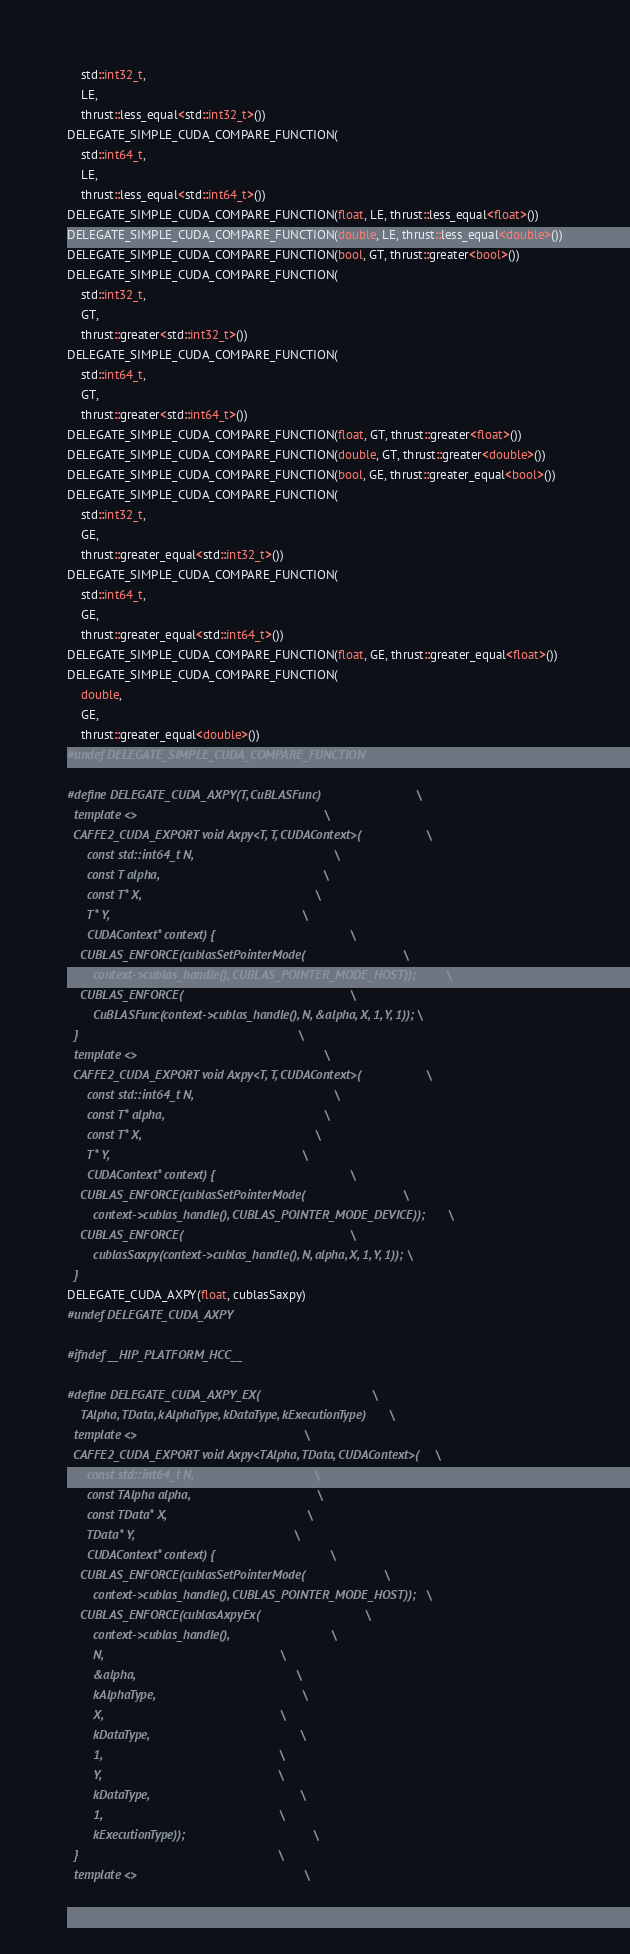Convert code to text. <code><loc_0><loc_0><loc_500><loc_500><_Cuda_>    std::int32_t,
    LE,
    thrust::less_equal<std::int32_t>())
DELEGATE_SIMPLE_CUDA_COMPARE_FUNCTION(
    std::int64_t,
    LE,
    thrust::less_equal<std::int64_t>())
DELEGATE_SIMPLE_CUDA_COMPARE_FUNCTION(float, LE, thrust::less_equal<float>())
DELEGATE_SIMPLE_CUDA_COMPARE_FUNCTION(double, LE, thrust::less_equal<double>())
DELEGATE_SIMPLE_CUDA_COMPARE_FUNCTION(bool, GT, thrust::greater<bool>())
DELEGATE_SIMPLE_CUDA_COMPARE_FUNCTION(
    std::int32_t,
    GT,
    thrust::greater<std::int32_t>())
DELEGATE_SIMPLE_CUDA_COMPARE_FUNCTION(
    std::int64_t,
    GT,
    thrust::greater<std::int64_t>())
DELEGATE_SIMPLE_CUDA_COMPARE_FUNCTION(float, GT, thrust::greater<float>())
DELEGATE_SIMPLE_CUDA_COMPARE_FUNCTION(double, GT, thrust::greater<double>())
DELEGATE_SIMPLE_CUDA_COMPARE_FUNCTION(bool, GE, thrust::greater_equal<bool>())
DELEGATE_SIMPLE_CUDA_COMPARE_FUNCTION(
    std::int32_t,
    GE,
    thrust::greater_equal<std::int32_t>())
DELEGATE_SIMPLE_CUDA_COMPARE_FUNCTION(
    std::int64_t,
    GE,
    thrust::greater_equal<std::int64_t>())
DELEGATE_SIMPLE_CUDA_COMPARE_FUNCTION(float, GE, thrust::greater_equal<float>())
DELEGATE_SIMPLE_CUDA_COMPARE_FUNCTION(
    double,
    GE,
    thrust::greater_equal<double>())
#undef DELEGATE_SIMPLE_CUDA_COMPARE_FUNCTION

#define DELEGATE_CUDA_AXPY(T, CuBLASFunc)                             \
  template <>                                                         \
  CAFFE2_CUDA_EXPORT void Axpy<T, T, CUDAContext>(                    \
      const std::int64_t N,                                           \
      const T alpha,                                                  \
      const T* X,                                                     \
      T* Y,                                                           \
      CUDAContext* context) {                                         \
    CUBLAS_ENFORCE(cublasSetPointerMode(                              \
        context->cublas_handle(), CUBLAS_POINTER_MODE_HOST));         \
    CUBLAS_ENFORCE(                                                   \
        CuBLASFunc(context->cublas_handle(), N, &alpha, X, 1, Y, 1)); \
  }                                                                   \
  template <>                                                         \
  CAFFE2_CUDA_EXPORT void Axpy<T, T, CUDAContext>(                    \
      const std::int64_t N,                                           \
      const T* alpha,                                                 \
      const T* X,                                                     \
      T* Y,                                                           \
      CUDAContext* context) {                                         \
    CUBLAS_ENFORCE(cublasSetPointerMode(                              \
        context->cublas_handle(), CUBLAS_POINTER_MODE_DEVICE));       \
    CUBLAS_ENFORCE(                                                   \
        cublasSaxpy(context->cublas_handle(), N, alpha, X, 1, Y, 1)); \
  }
DELEGATE_CUDA_AXPY(float, cublasSaxpy)
#undef DELEGATE_CUDA_AXPY

#ifndef __HIP_PLATFORM_HCC__

#define DELEGATE_CUDA_AXPY_EX(                                  \
    TAlpha, TData, kAlphaType, kDataType, kExecutionType)       \
  template <>                                                   \
  CAFFE2_CUDA_EXPORT void Axpy<TAlpha, TData, CUDAContext>(     \
      const std::int64_t N,                                     \
      const TAlpha alpha,                                       \
      const TData* X,                                           \
      TData* Y,                                                 \
      CUDAContext* context) {                                   \
    CUBLAS_ENFORCE(cublasSetPointerMode(                        \
        context->cublas_handle(), CUBLAS_POINTER_MODE_HOST));   \
    CUBLAS_ENFORCE(cublasAxpyEx(                                \
        context->cublas_handle(),                               \
        N,                                                      \
        &alpha,                                                 \
        kAlphaType,                                             \
        X,                                                      \
        kDataType,                                              \
        1,                                                      \
        Y,                                                      \
        kDataType,                                              \
        1,                                                      \
        kExecutionType));                                       \
  }                                                             \
  template <>                                                   \</code> 